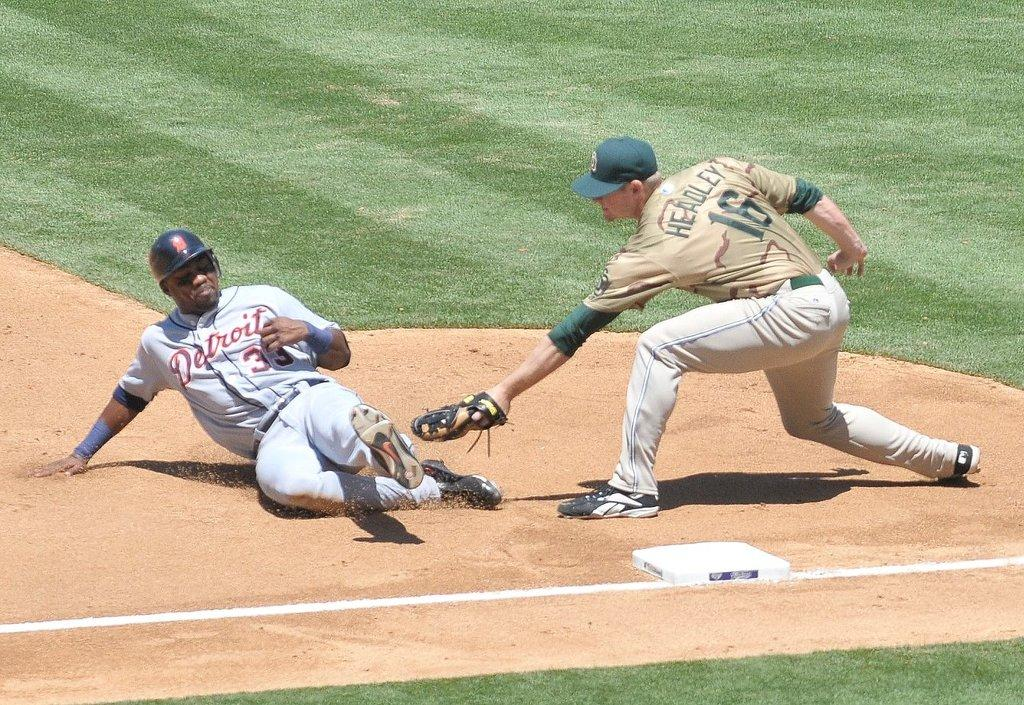How many baseball players are in the image? There are two baseball players in the image. Where are the baseball players located? The baseball players are on a ground. What type of business do the baseball players own in the image? There is no indication in the image that the baseball players own a business. 